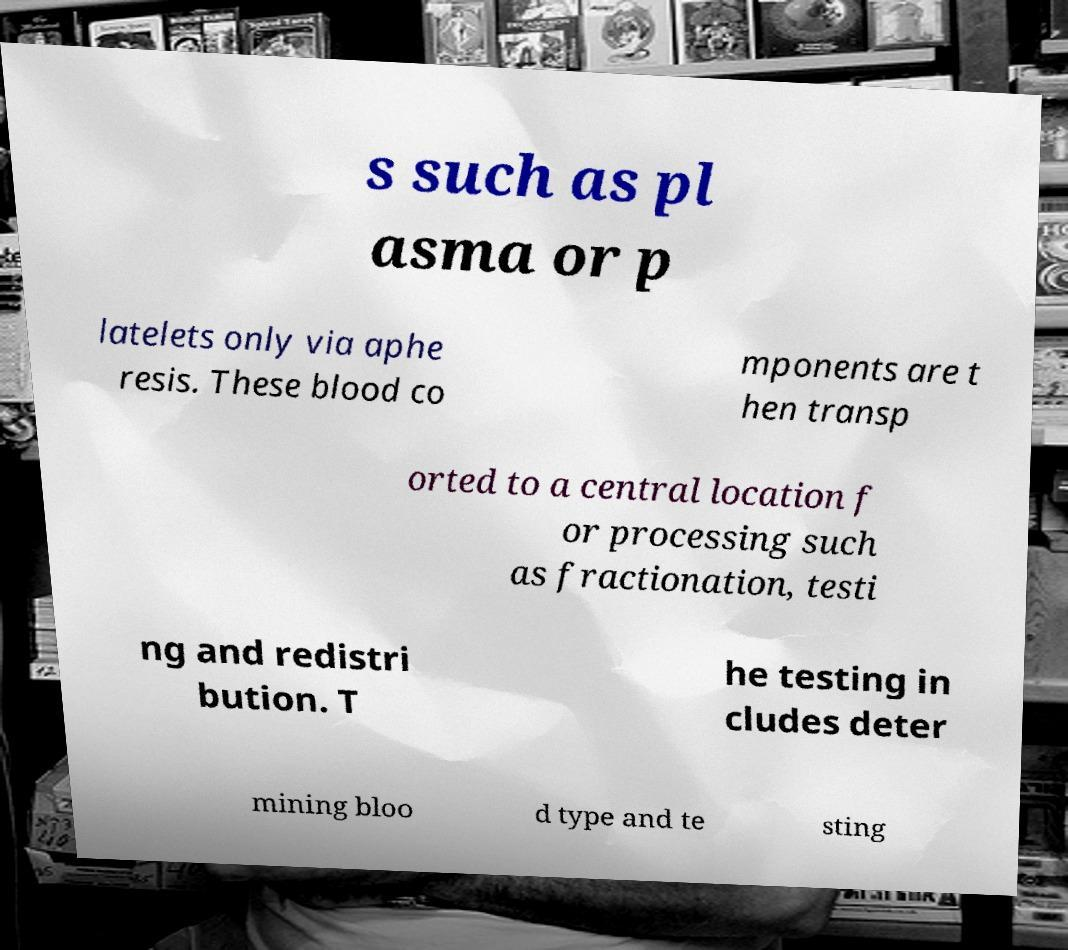Please read and relay the text visible in this image. What does it say? s such as pl asma or p latelets only via aphe resis. These blood co mponents are t hen transp orted to a central location f or processing such as fractionation, testi ng and redistri bution. T he testing in cludes deter mining bloo d type and te sting 